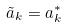Convert formula to latex. <formula><loc_0><loc_0><loc_500><loc_500>\tilde { a } _ { k } = a _ { k } ^ { * }</formula> 